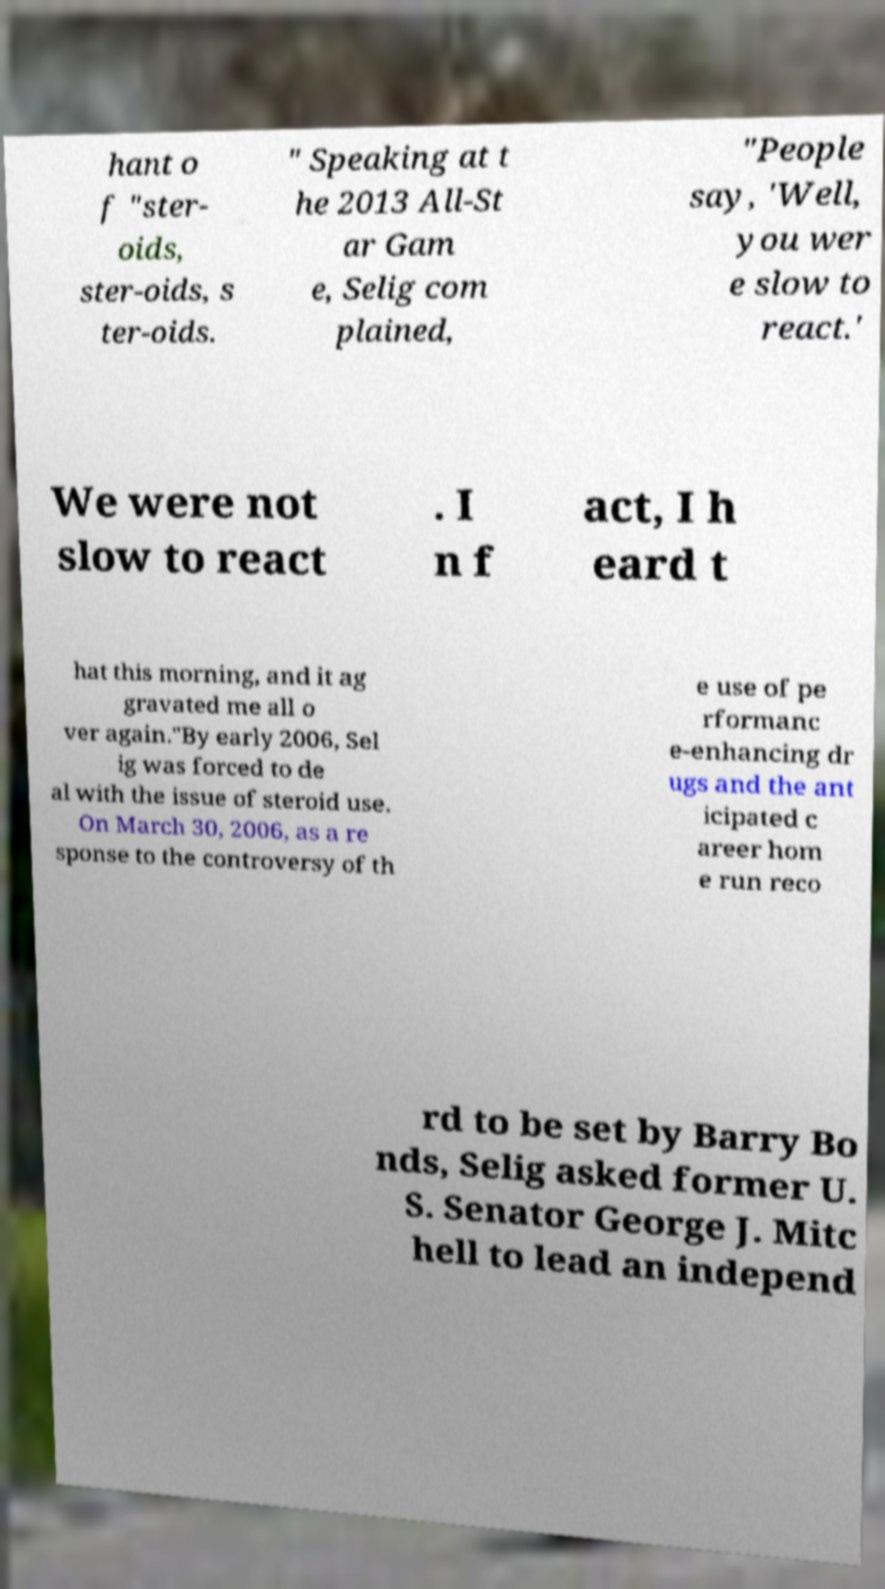What messages or text are displayed in this image? I need them in a readable, typed format. hant o f "ster- oids, ster-oids, s ter-oids. " Speaking at t he 2013 All-St ar Gam e, Selig com plained, "People say, 'Well, you wer e slow to react.' We were not slow to react . I n f act, I h eard t hat this morning, and it ag gravated me all o ver again."By early 2006, Sel ig was forced to de al with the issue of steroid use. On March 30, 2006, as a re sponse to the controversy of th e use of pe rformanc e-enhancing dr ugs and the ant icipated c areer hom e run reco rd to be set by Barry Bo nds, Selig asked former U. S. Senator George J. Mitc hell to lead an independ 